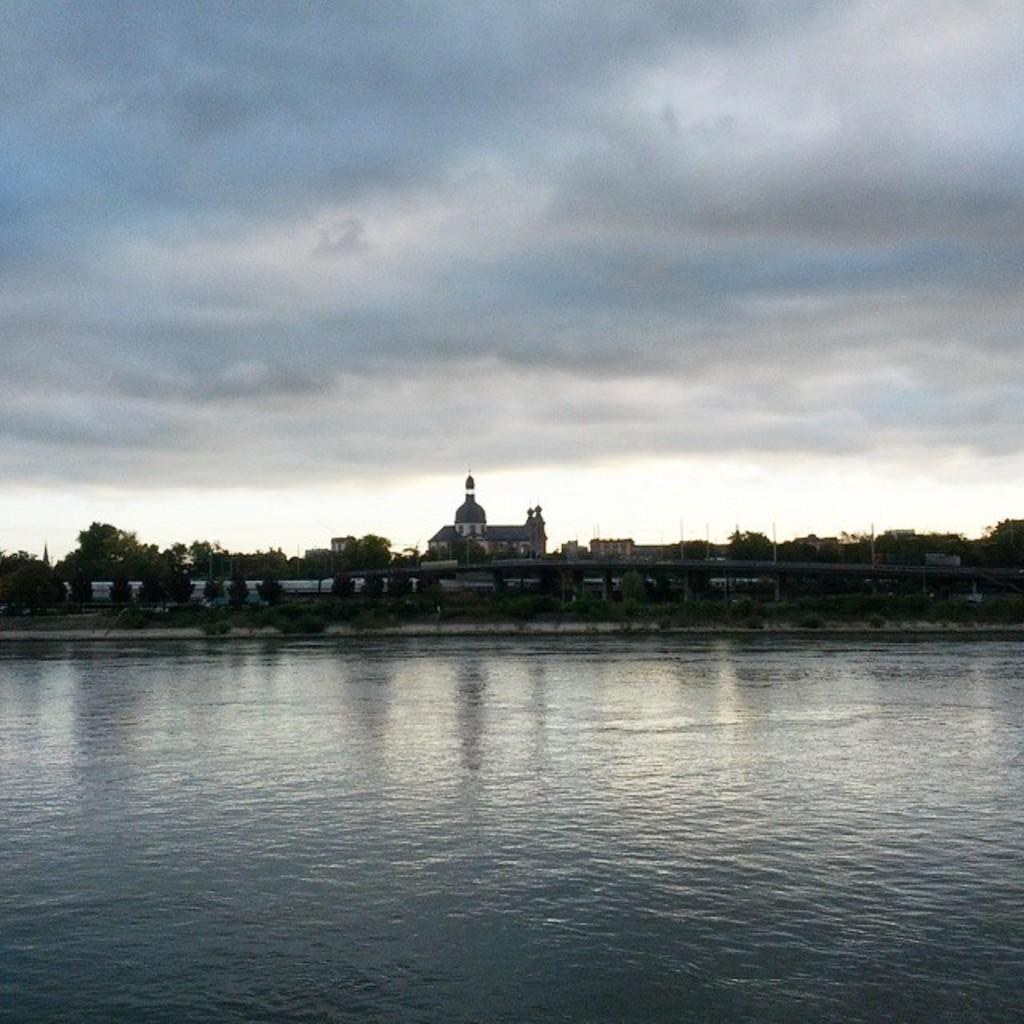What is the main feature of the image? The main feature of the image is water. What can be seen near the water? There are many trees near the water. Is there any man-made structure visible in the image? Yes, there is a bridge in the image. What else can be seen in the image besides the water and trees? There are buildings in the image. What is visible in the background of the image? There are clouds and the sky visible in the background of the image. What type of paper can be seen floating on the water in the image? There is no paper visible in the image; it only features water, trees, a bridge, buildings, clouds, and the sky. How many mice are sitting on the bridge in the image? There are no mice present in the image; it only features water, trees, a bridge, buildings, clouds, and the sky. 